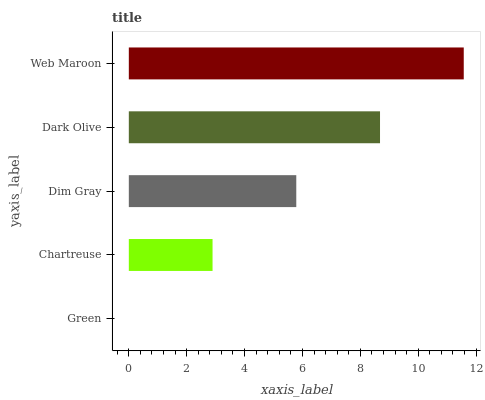Is Green the minimum?
Answer yes or no. Yes. Is Web Maroon the maximum?
Answer yes or no. Yes. Is Chartreuse the minimum?
Answer yes or no. No. Is Chartreuse the maximum?
Answer yes or no. No. Is Chartreuse greater than Green?
Answer yes or no. Yes. Is Green less than Chartreuse?
Answer yes or no. Yes. Is Green greater than Chartreuse?
Answer yes or no. No. Is Chartreuse less than Green?
Answer yes or no. No. Is Dim Gray the high median?
Answer yes or no. Yes. Is Dim Gray the low median?
Answer yes or no. Yes. Is Dark Olive the high median?
Answer yes or no. No. Is Chartreuse the low median?
Answer yes or no. No. 